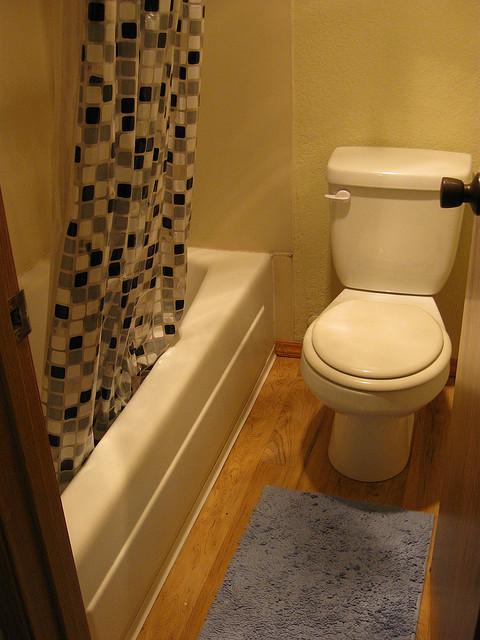Which side of the tank has the flush handle?
Be succinct. Left. Is the shower curtain completely closed?
Keep it brief. No. Is the shower running?
Write a very short answer. No. Is this a bathroom typically found in North America?
Keep it brief. Yes. What color is the rug?
Give a very brief answer. Blue. What is the pattern on the shower curtain?
Keep it brief. Checkered. 